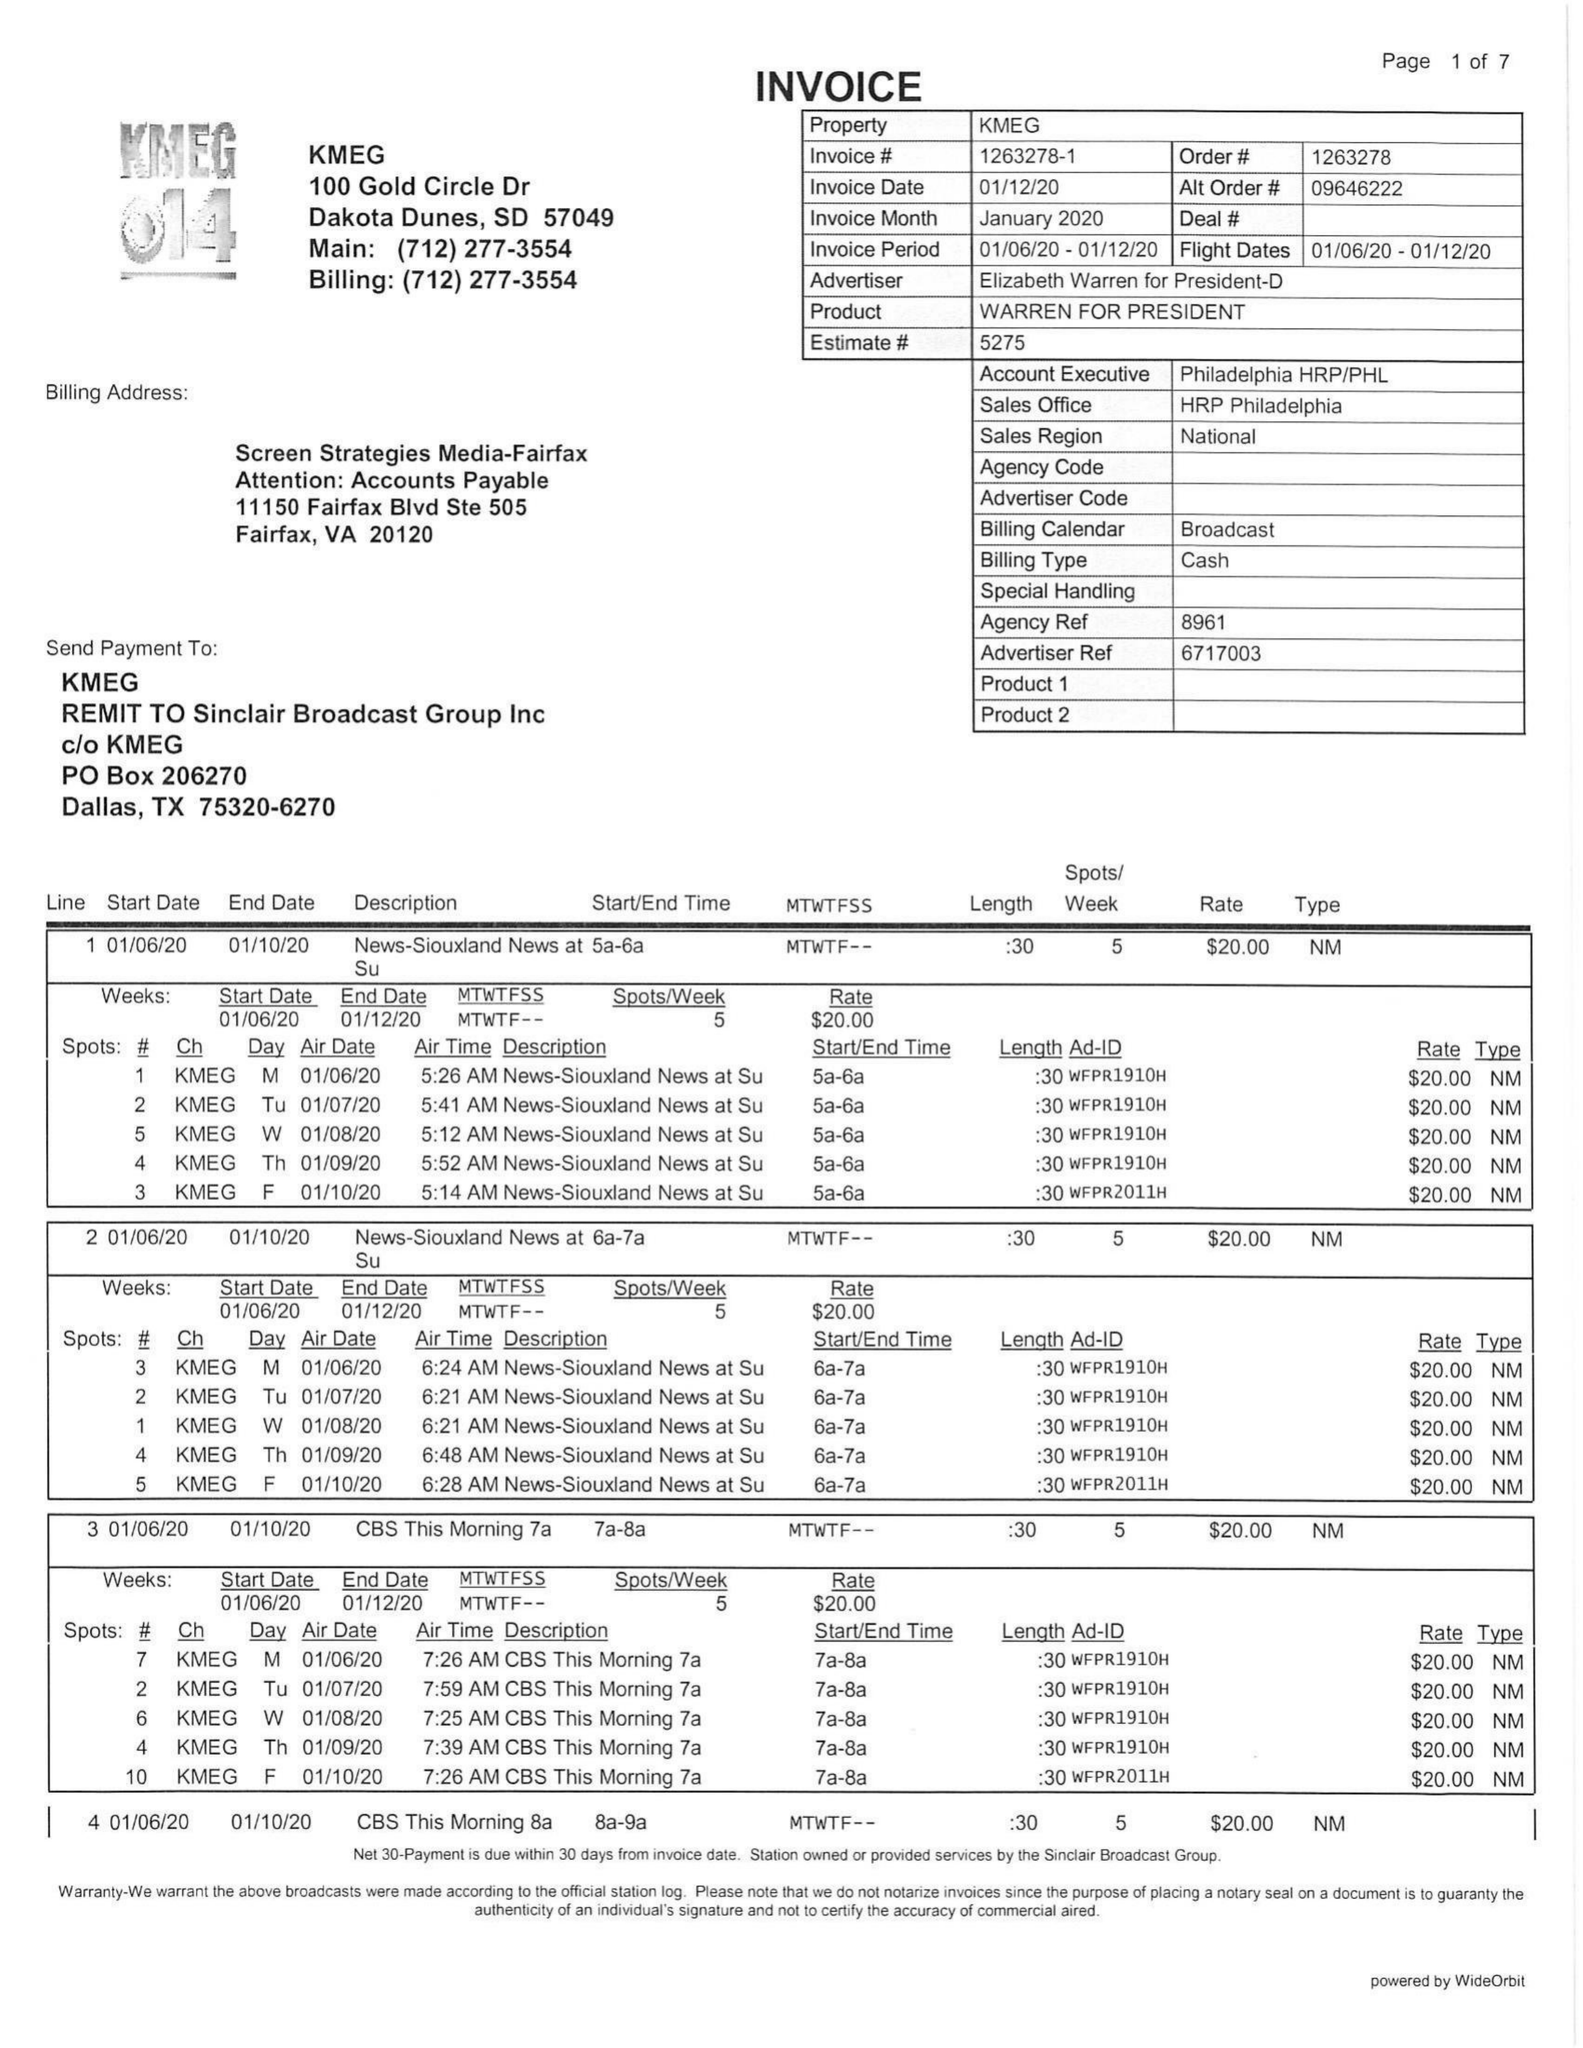What is the value for the flight_from?
Answer the question using a single word or phrase. 01/06/20 